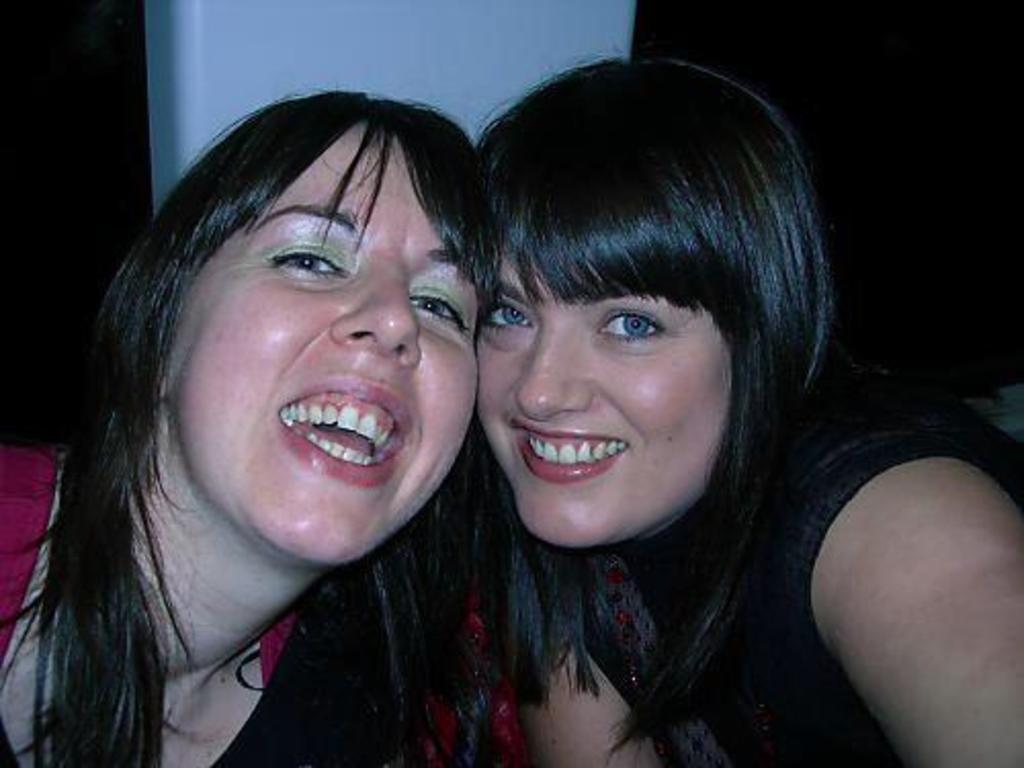How many people are in the image? There are two women in the image. What is the facial expression of the women? The women are smiling. What can be observed about the background of the image? The background of the image is dark. What is the color of the pillar in the image? There is a white color pillar in the image. What type of shirt is the page wearing in the image? There is no page or shirt present in the image; it features two women and a white pillar. What type of trade is being conducted in the image? There is no trade being conducted in the image; it only shows two women and a white pillar. 